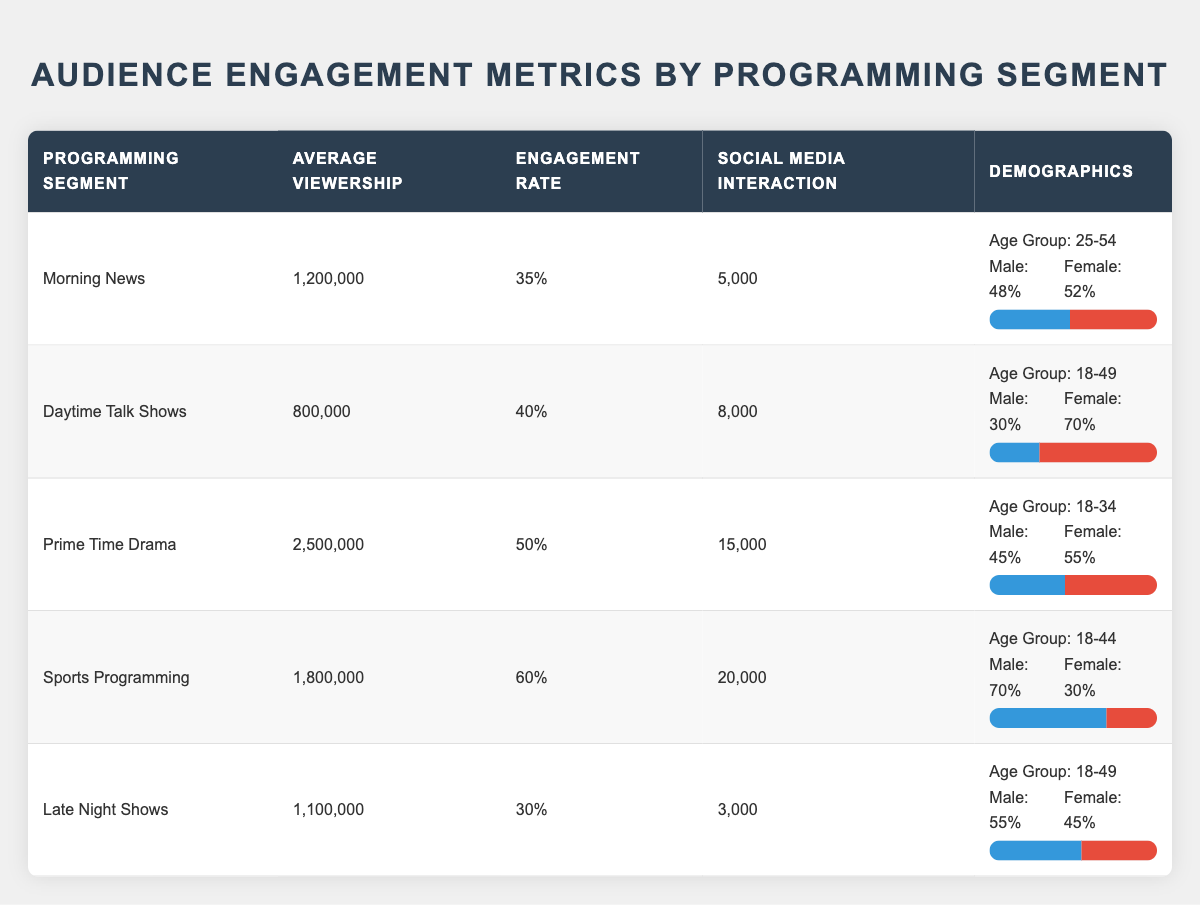What is the programming segment with the highest average viewership? Looking through the table, the Prime Time Drama segment has the highest average viewership at 2,500,000.
Answer: Prime Time Drama Which programming segment has the lowest engagement rate? The engagement rates for each segment are: Morning News (35%), Daytime Talk Shows (40%), Prime Time Drama (50%), Sports Programming (60%), and Late Night Shows (30%). The lowest is Late Night Shows at 30%.
Answer: Late Night Shows How many social media interactions does Sports Programming have? According to the table, Sports Programming has 20,000 social media interactions.
Answer: 20,000 What is the gender ratio of the Daytime Talk Shows segment? The gender ratio for Daytime Talk Shows is 30% Male and 70% Female.
Answer: 30% Male, 70% Female What is the average viewership of programs geared towards the 18-49 age group? The relevant segments for the 18-49 age group are Daytime Talk Shows (800,000), Prime Time Drama (2,500,000), and Late Night Shows (1,100,000). Their average is (800,000 + 2,500,000 + 1,100,000) / 3 = 1,133,333.
Answer: 1,133,333 Is the engagement rate of Sports Programming higher than that of Prime Time Drama? The engagement rates are Sports Programming at 60% and Prime Time Drama at 50%. Since 60% is greater than 50%, it confirms that Sports Programming has a higher engagement rate.
Answer: Yes What demographic has the highest social media interactions? Reviewing the interactions: Morning News (5,000), Daytime Talk Shows (8,000), Prime Time Drama (15,000), Sports Programming (20,000), and Late Night Shows (3,000). Sports Programming leads with 20,000 interactions.
Answer: Sports Programming Calculate the total average viewership of all programming segments combined. Adding the viewership: 1,200,000 + 800,000 + 2,500,000 + 1,800,000 + 1,100,000 = 7,400,000. The total average viewership across all segments is 7,400,000.
Answer: 7,400,000 Do Late Night Shows have a higher percentage of male viewers than Daytime Talk Shows? The male viewer percentages are Late Night Shows (55%) and Daytime Talk Shows (30%). Since 55% is greater than 30%, Late Night Shows do have a higher percentage of male viewers.
Answer: Yes Which programming segment has the highest engagement rate and how does it compare to the lowest? The highest engagement rate is Sports Programming at 60%, while the lowest is Late Night Shows at 30%. The difference is 60% - 30% = 30%, indicating a significant engagement rate gap.
Answer: 30% difference 